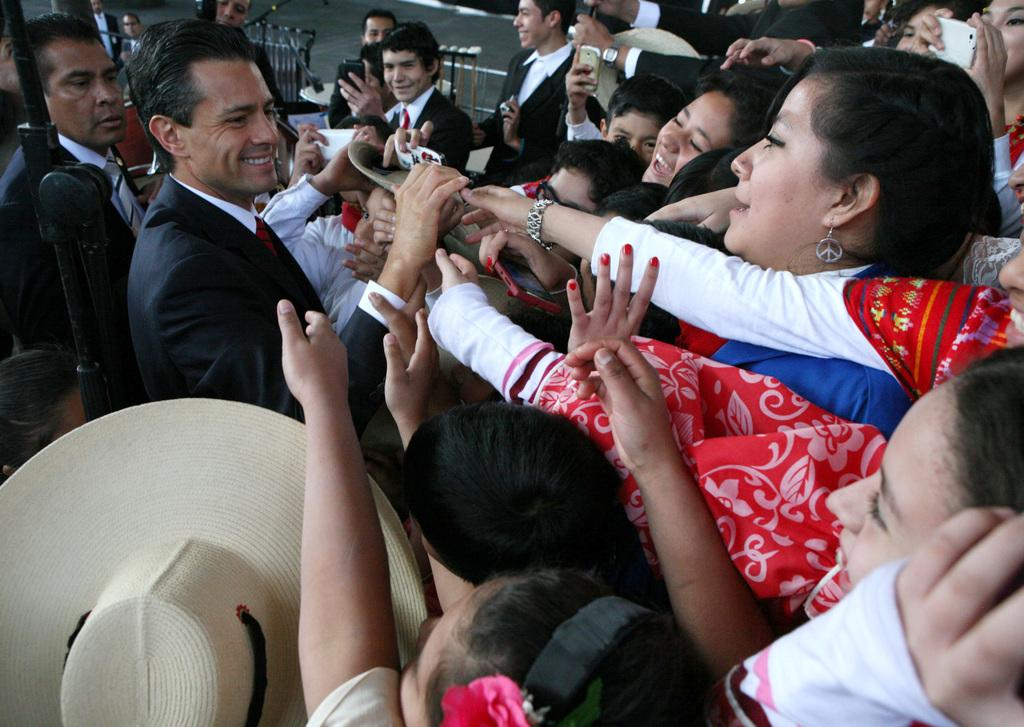What can be seen on the heads of some people in the image? There is a hat in the image. How many people are present in the image? There is a group of people standing in the image. What are the people holding in their hands? The people are holding objects. What type of architectural feature can be seen in the image? There are iron grills in the image. Can you see a brick floating on the lake in the image? There is no lake or brick present in the image. What happens when the people smash the iron grills in the image? There is no smashing of iron grills depicted in the image. 